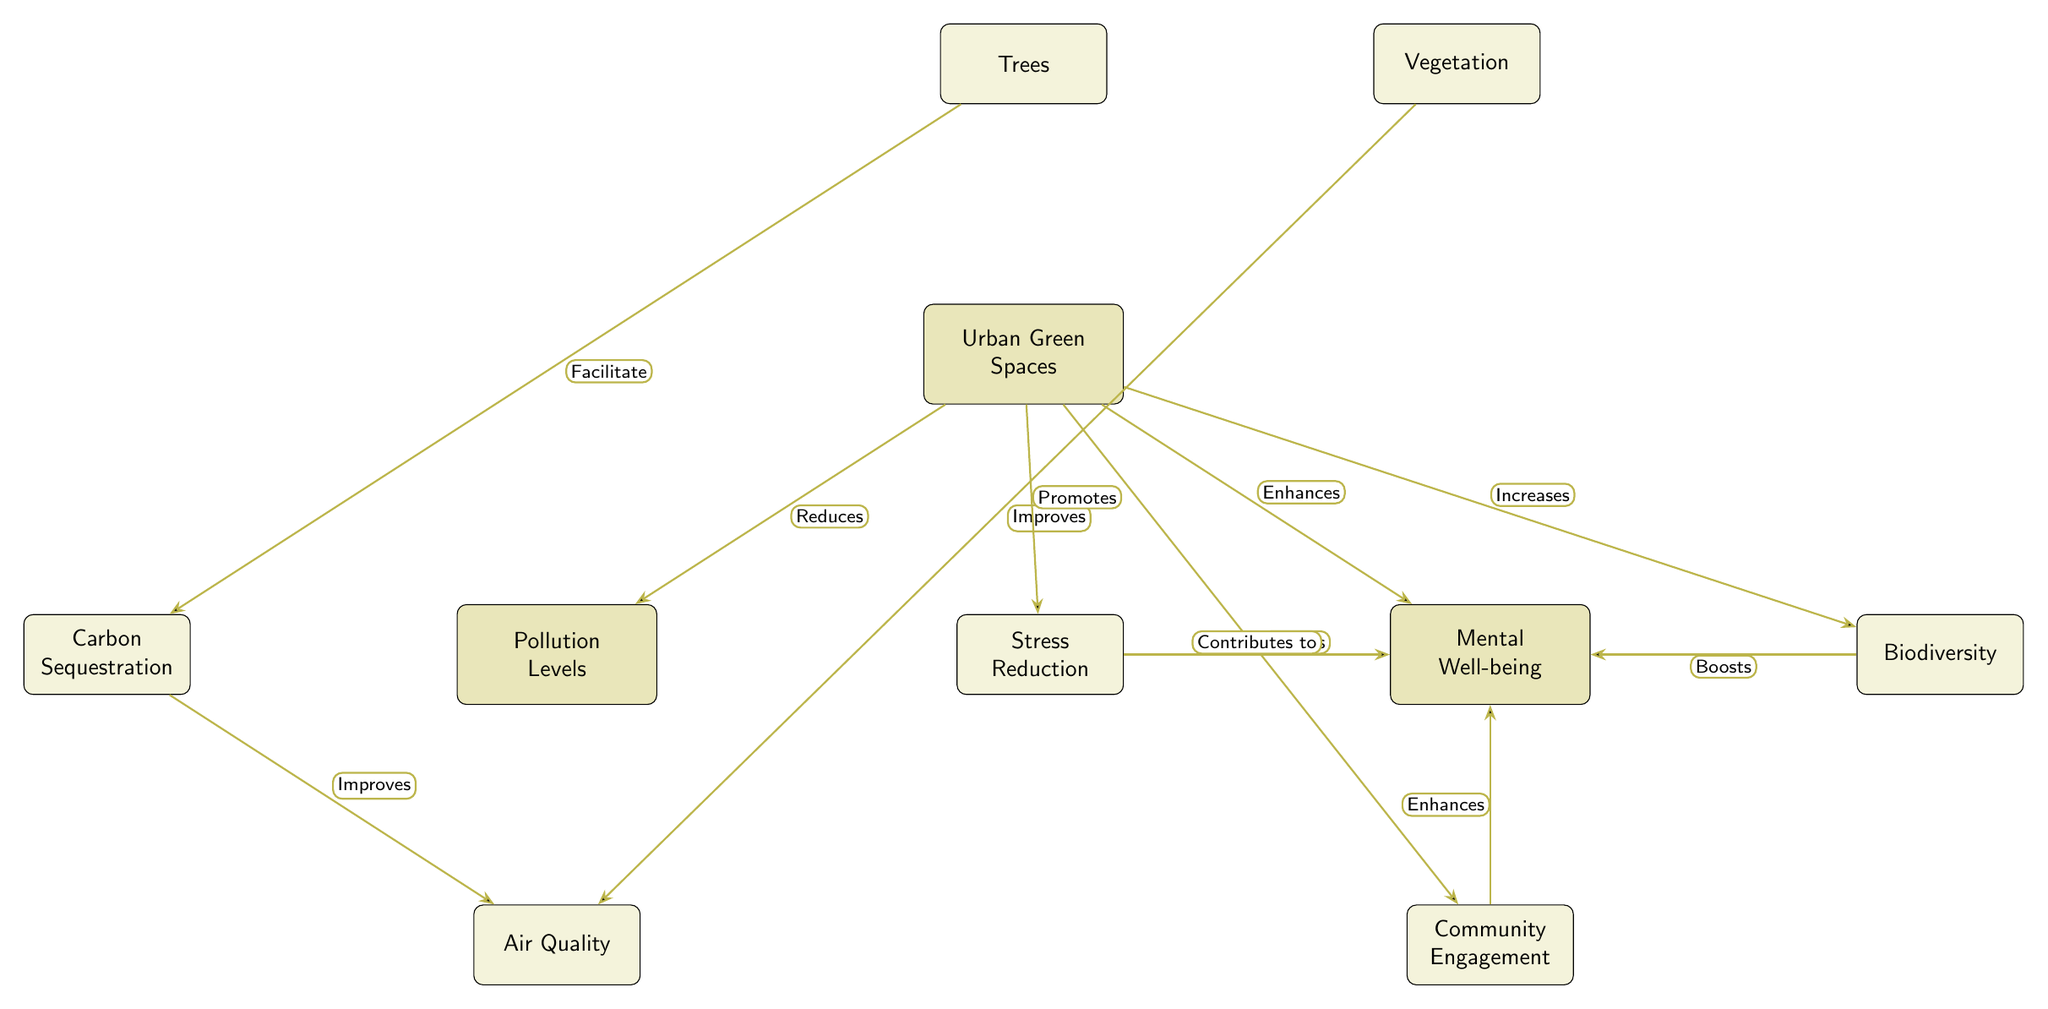What is the main focus of the diagram? The diagram focuses on the interplay between Urban Green Spaces and two primary outcomes: Pollution Levels and Mental Well-being.
Answer: Urban Green Spaces What effect do Urban Green Spaces have on Pollution Levels? The diagram indicates that Urban Green Spaces "Reduces" Pollution Levels.
Answer: Reduces What enhances Mental Well-being according to the diagram? The diagram shows that Urban Green Spaces "Enhances" Mental Well-being.
Answer: Enhances How many nodes are connected to the Mental Well-being node? The Mental Well-being node is connected to three sub-nodes: Stress Reduction, Biodiversity, and Community Engagement. Thus, there are three connected nodes.
Answer: 3 What contributes to Stress Reduction in the diagram? The diagram shows that Urban Green Spaces "Promotes" Stress Reduction, which then "Contributes to" Mental Well-being.
Answer: Urban Green Spaces What is the relationship between Trees and Carbon Sequestration? The diagram indicates that Trees "Facilitate" Carbon Sequestration.
Answer: Facilitate Which aspect does Biodiversity boost according to the diagram? The diagram illustrates that Biodiversity "Boosts" Mental Well-being.
Answer: Mental Well-being How does Carbon Sequestration affect Air Quality? According to the diagram, Carbon Sequestration "Improves" Air Quality.
Answer: Improves What is the role of Vegetation regarding Air Quality? The diagram indicates that Vegetation "Improves" Air Quality as well.
Answer: Improves 